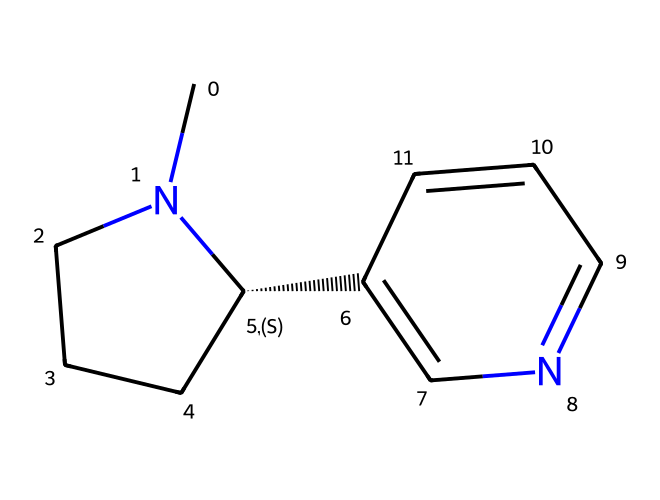What is the molecular formula of nicotine? To find the molecular formula, we need to sum the total number of each type of atom present in the structure. From the SMILES representation, we can count 10 carbons (C), 14 hydrogens (H), and 2 nitrogens (N). Thus, the molecular formula is C10H14N2.
Answer: C10H14N2 How many nitrogen atoms are in this structure? By analyzing the SMILES representation, we can identify the nitrogen atoms (N). In the given structure, there are two instances of nitrogen present. Therefore, the number of nitrogen atoms is two.
Answer: 2 What type of chemical structure is nicotine categorized as? Nicotine is categorized as an alkaloid based on its structure, which contains a nitrogen atom and exhibits physiological effects. Alkaloids are known for their basic nature and special bioactivity.
Answer: alkaloid What type of bonding characterizes the ring structures in nicotine? The ring structures in nicotine involve predominantly sigma bonds and some pi bonds. The rings are formed using carbon and nitrogen atoms connected through single (sigma) and double (pi) bonds.
Answer: sigma and pi Which part of the chemical structure indicates it has psychoactive properties? The presence of the nitrogen atoms in the structure is critical; nitrogen atoms contribute to the basicity and reactivity associated with psychoactive effects, as they can interact with neurotransmitter receptors.
Answer: nitrogen atoms What is the total number of rings present in nicotine? From the SMILES representation, we can observe that there are two distinct ring structures in nicotine. Each ring is formed by the connectivity of carbon and nitrogen atoms in a cyclic manner.
Answer: 2 